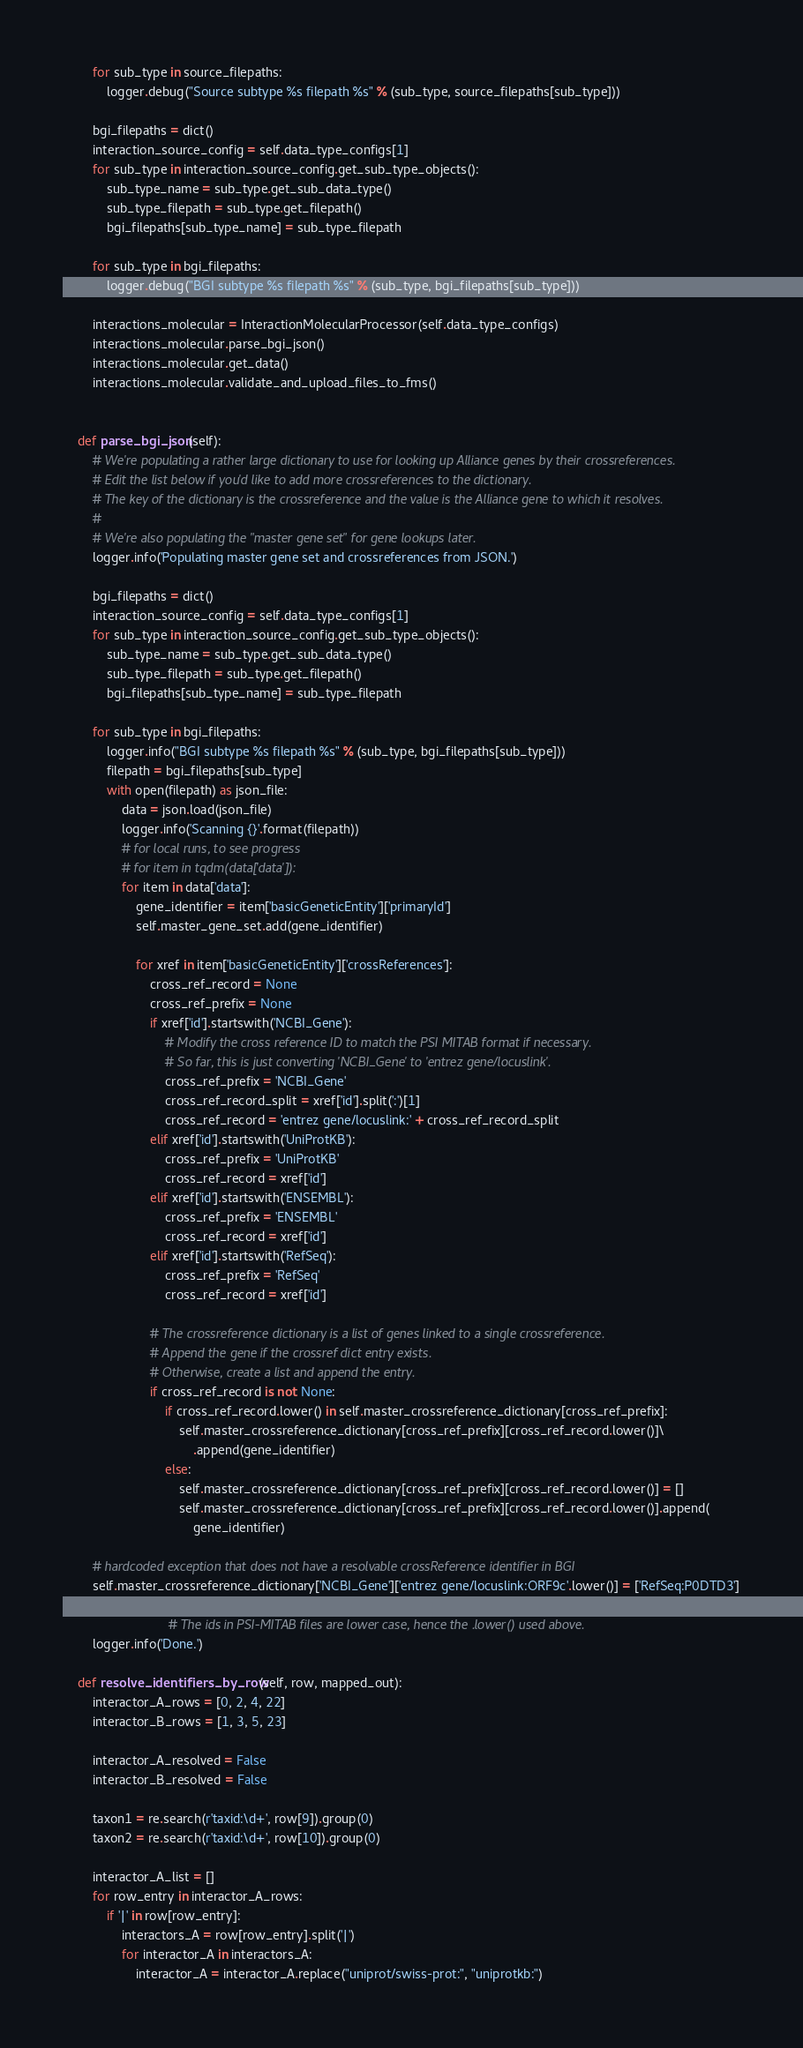<code> <loc_0><loc_0><loc_500><loc_500><_Python_>
        for sub_type in source_filepaths:
            logger.debug("Source subtype %s filepath %s" % (sub_type, source_filepaths[sub_type]))

        bgi_filepaths = dict()
        interaction_source_config = self.data_type_configs[1]
        for sub_type in interaction_source_config.get_sub_type_objects():
            sub_type_name = sub_type.get_sub_data_type()
            sub_type_filepath = sub_type.get_filepath()
            bgi_filepaths[sub_type_name] = sub_type_filepath

        for sub_type in bgi_filepaths:
            logger.debug("BGI subtype %s filepath %s" % (sub_type, bgi_filepaths[sub_type]))

        interactions_molecular = InteractionMolecularProcessor(self.data_type_configs)
        interactions_molecular.parse_bgi_json()
        interactions_molecular.get_data()
        interactions_molecular.validate_and_upload_files_to_fms()


    def parse_bgi_json(self):
        # We're populating a rather large dictionary to use for looking up Alliance genes by their crossreferences.
        # Edit the list below if you'd like to add more crossreferences to the dictionary.
        # The key of the dictionary is the crossreference and the value is the Alliance gene to which it resolves.
        #
        # We're also populating the "master gene set" for gene lookups later.
        logger.info('Populating master gene set and crossreferences from JSON.')

        bgi_filepaths = dict()
        interaction_source_config = self.data_type_configs[1]
        for sub_type in interaction_source_config.get_sub_type_objects():
            sub_type_name = sub_type.get_sub_data_type()
            sub_type_filepath = sub_type.get_filepath()
            bgi_filepaths[sub_type_name] = sub_type_filepath

        for sub_type in bgi_filepaths:
            logger.info("BGI subtype %s filepath %s" % (sub_type, bgi_filepaths[sub_type]))
            filepath = bgi_filepaths[sub_type]
            with open(filepath) as json_file:
                data = json.load(json_file)
                logger.info('Scanning {}'.format(filepath))
                # for local runs, to see progress
                # for item in tqdm(data['data']):
                for item in data['data']:
                    gene_identifier = item['basicGeneticEntity']['primaryId']
                    self.master_gene_set.add(gene_identifier)

                    for xref in item['basicGeneticEntity']['crossReferences']:
                        cross_ref_record = None
                        cross_ref_prefix = None
                        if xref['id'].startswith('NCBI_Gene'):
                            # Modify the cross reference ID to match the PSI MITAB format if necessary.
                            # So far, this is just converting 'NCBI_Gene' to 'entrez gene/locuslink'.
                            cross_ref_prefix = 'NCBI_Gene'
                            cross_ref_record_split = xref['id'].split(':')[1]
                            cross_ref_record = 'entrez gene/locuslink:' + cross_ref_record_split
                        elif xref['id'].startswith('UniProtKB'):
                            cross_ref_prefix = 'UniProtKB'
                            cross_ref_record = xref['id']
                        elif xref['id'].startswith('ENSEMBL'):
                            cross_ref_prefix = 'ENSEMBL'
                            cross_ref_record = xref['id']
                        elif xref['id'].startswith('RefSeq'):
                            cross_ref_prefix = 'RefSeq'
                            cross_ref_record = xref['id']

                        # The crossreference dictionary is a list of genes linked to a single crossreference.
                        # Append the gene if the crossref dict entry exists.
                        # Otherwise, create a list and append the entry.
                        if cross_ref_record is not None:
                            if cross_ref_record.lower() in self.master_crossreference_dictionary[cross_ref_prefix]:
                                self.master_crossreference_dictionary[cross_ref_prefix][cross_ref_record.lower()]\
                                    .append(gene_identifier)
                            else:
                                self.master_crossreference_dictionary[cross_ref_prefix][cross_ref_record.lower()] = []
                                self.master_crossreference_dictionary[cross_ref_prefix][cross_ref_record.lower()].append(
                                    gene_identifier)

        # hardcoded exception that does not have a resolvable crossReference identifier in BGI
        self.master_crossreference_dictionary['NCBI_Gene']['entrez gene/locuslink:ORF9c'.lower()] = ['RefSeq:P0DTD3']

                             # The ids in PSI-MITAB files are lower case, hence the .lower() used above.
        logger.info('Done.')

    def resolve_identifiers_by_row(self, row, mapped_out):
        interactor_A_rows = [0, 2, 4, 22]
        interactor_B_rows = [1, 3, 5, 23]

        interactor_A_resolved = False
        interactor_B_resolved = False

        taxon1 = re.search(r'taxid:\d+', row[9]).group(0)
        taxon2 = re.search(r'taxid:\d+', row[10]).group(0)

        interactor_A_list = []
        for row_entry in interactor_A_rows:
            if '|' in row[row_entry]:
                interactors_A = row[row_entry].split('|')
                for interactor_A in interactors_A:
                    interactor_A = interactor_A.replace("uniprot/swiss-prot:", "uniprotkb:")</code> 